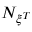Convert formula to latex. <formula><loc_0><loc_0><loc_500><loc_500>N _ { { \xi } ^ { T } }</formula> 